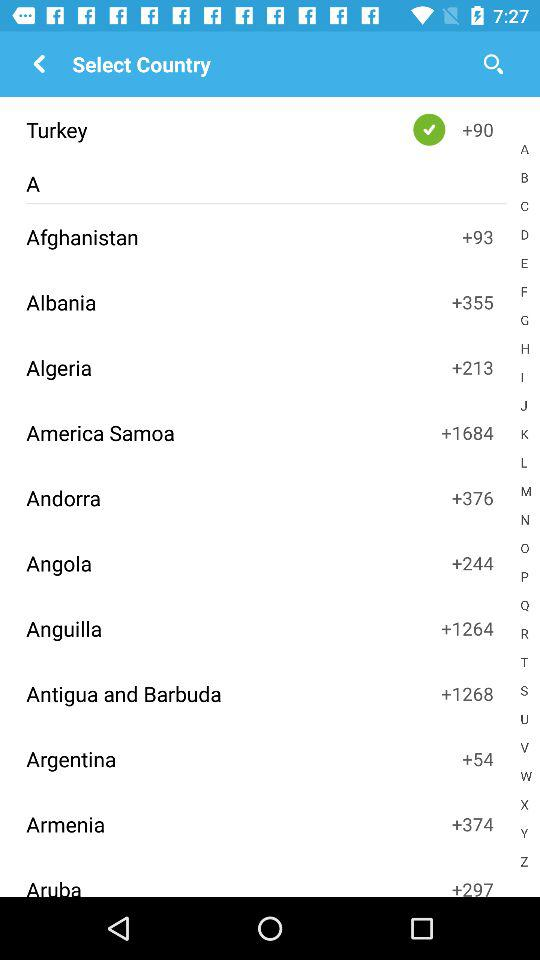Which country is selected? The selected country is Turkey. 